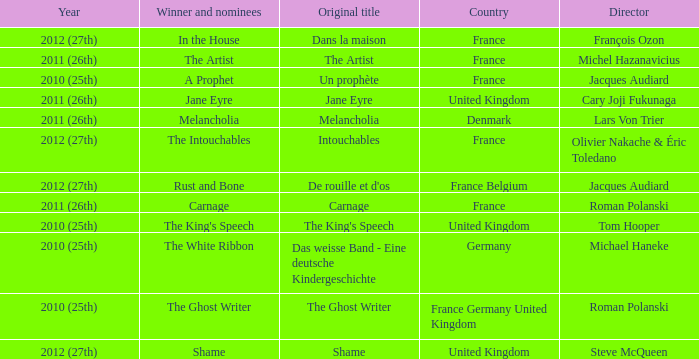Who was the director of the king's speech? Tom Hooper. 